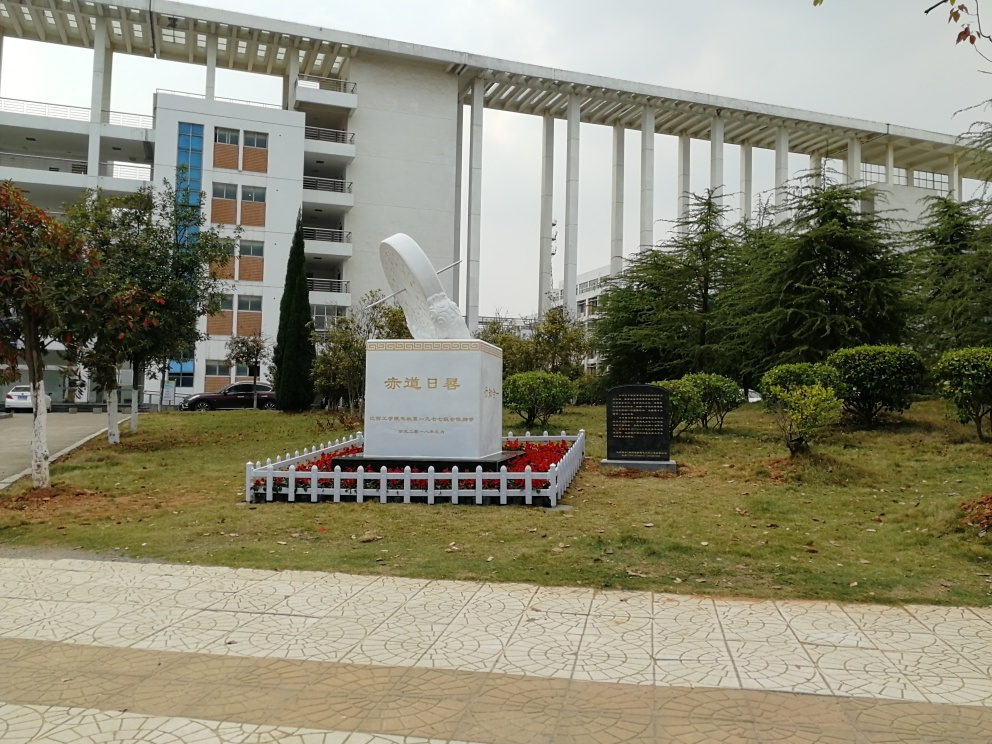What is the condition of the building in the image?
A. Completely washed out
B. Retains most of its texture and detail
C. Completely lost its detail
Answer with the option's letter from the given choices directly.
 B. 